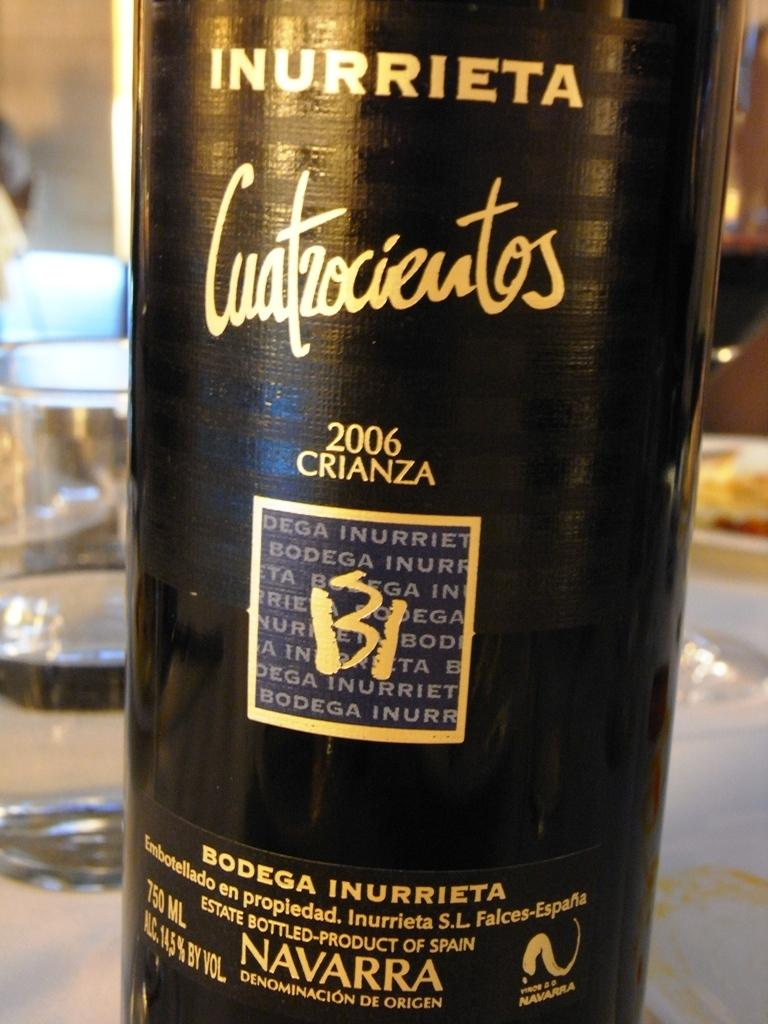<image>
Describe the image concisely. Black bottle with black label that says the year 2006 on it. 